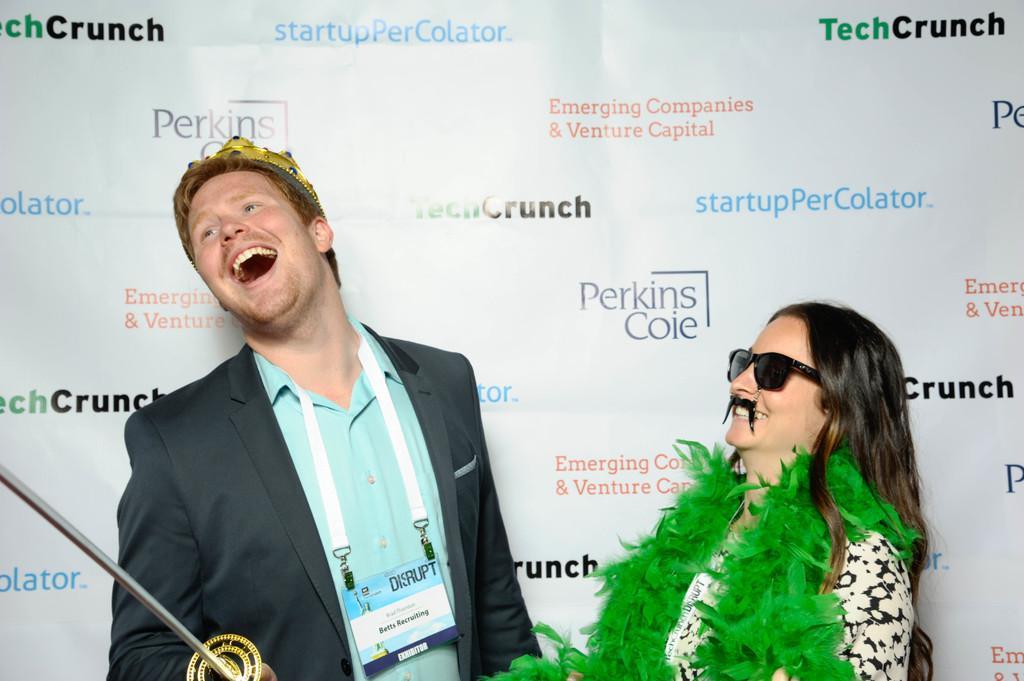Could you give a brief overview of what you see in this image? In this picture we can see a man wearing a crown on his head and holding a sword in his hand. He is smiling. There is a woman wearing goggles on her eyes and a mustache on her mouth. She is wearing a green fluffy, feathery scarf and smiling. We can see some text on a white surface. 